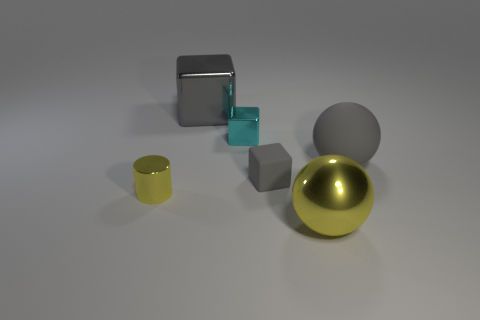Add 2 small yellow cylinders. How many objects exist? 8 Subtract all cylinders. How many objects are left? 5 Subtract all gray matte spheres. Subtract all tiny blue metallic things. How many objects are left? 5 Add 5 tiny things. How many tiny things are left? 8 Add 3 large brown rubber things. How many large brown rubber things exist? 3 Subtract 1 yellow cylinders. How many objects are left? 5 